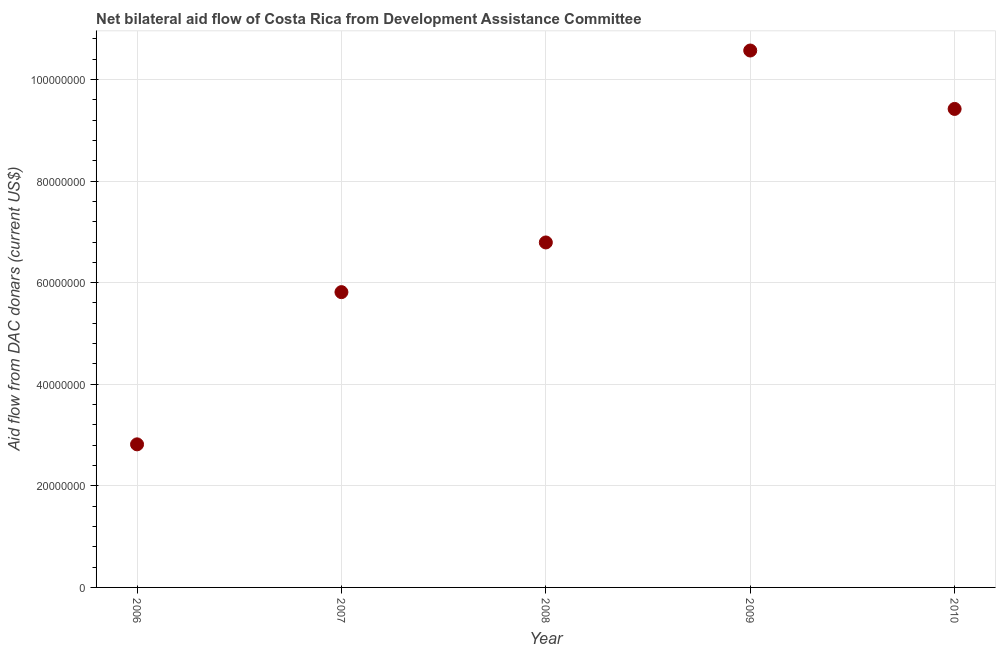What is the net bilateral aid flows from dac donors in 2010?
Your answer should be compact. 9.42e+07. Across all years, what is the maximum net bilateral aid flows from dac donors?
Keep it short and to the point. 1.06e+08. Across all years, what is the minimum net bilateral aid flows from dac donors?
Offer a very short reply. 2.82e+07. What is the sum of the net bilateral aid flows from dac donors?
Provide a succinct answer. 3.54e+08. What is the difference between the net bilateral aid flows from dac donors in 2006 and 2010?
Provide a succinct answer. -6.60e+07. What is the average net bilateral aid flows from dac donors per year?
Provide a succinct answer. 7.08e+07. What is the median net bilateral aid flows from dac donors?
Offer a terse response. 6.79e+07. What is the ratio of the net bilateral aid flows from dac donors in 2008 to that in 2009?
Offer a terse response. 0.64. Is the net bilateral aid flows from dac donors in 2006 less than that in 2008?
Ensure brevity in your answer.  Yes. Is the difference between the net bilateral aid flows from dac donors in 2006 and 2010 greater than the difference between any two years?
Your answer should be very brief. No. What is the difference between the highest and the second highest net bilateral aid flows from dac donors?
Provide a short and direct response. 1.15e+07. Is the sum of the net bilateral aid flows from dac donors in 2006 and 2009 greater than the maximum net bilateral aid flows from dac donors across all years?
Provide a succinct answer. Yes. What is the difference between the highest and the lowest net bilateral aid flows from dac donors?
Offer a very short reply. 7.75e+07. Does the net bilateral aid flows from dac donors monotonically increase over the years?
Your response must be concise. No. How many years are there in the graph?
Ensure brevity in your answer.  5. Does the graph contain grids?
Offer a terse response. Yes. What is the title of the graph?
Your answer should be very brief. Net bilateral aid flow of Costa Rica from Development Assistance Committee. What is the label or title of the X-axis?
Provide a succinct answer. Year. What is the label or title of the Y-axis?
Your answer should be very brief. Aid flow from DAC donars (current US$). What is the Aid flow from DAC donars (current US$) in 2006?
Your answer should be very brief. 2.82e+07. What is the Aid flow from DAC donars (current US$) in 2007?
Make the answer very short. 5.81e+07. What is the Aid flow from DAC donars (current US$) in 2008?
Give a very brief answer. 6.79e+07. What is the Aid flow from DAC donars (current US$) in 2009?
Give a very brief answer. 1.06e+08. What is the Aid flow from DAC donars (current US$) in 2010?
Offer a very short reply. 9.42e+07. What is the difference between the Aid flow from DAC donars (current US$) in 2006 and 2007?
Offer a very short reply. -3.00e+07. What is the difference between the Aid flow from DAC donars (current US$) in 2006 and 2008?
Ensure brevity in your answer.  -3.98e+07. What is the difference between the Aid flow from DAC donars (current US$) in 2006 and 2009?
Ensure brevity in your answer.  -7.75e+07. What is the difference between the Aid flow from DAC donars (current US$) in 2006 and 2010?
Your answer should be compact. -6.60e+07. What is the difference between the Aid flow from DAC donars (current US$) in 2007 and 2008?
Offer a terse response. -9.78e+06. What is the difference between the Aid flow from DAC donars (current US$) in 2007 and 2009?
Give a very brief answer. -4.76e+07. What is the difference between the Aid flow from DAC donars (current US$) in 2007 and 2010?
Give a very brief answer. -3.61e+07. What is the difference between the Aid flow from DAC donars (current US$) in 2008 and 2009?
Your answer should be compact. -3.78e+07. What is the difference between the Aid flow from DAC donars (current US$) in 2008 and 2010?
Provide a short and direct response. -2.63e+07. What is the difference between the Aid flow from DAC donars (current US$) in 2009 and 2010?
Your response must be concise. 1.15e+07. What is the ratio of the Aid flow from DAC donars (current US$) in 2006 to that in 2007?
Your answer should be compact. 0.48. What is the ratio of the Aid flow from DAC donars (current US$) in 2006 to that in 2008?
Offer a very short reply. 0.41. What is the ratio of the Aid flow from DAC donars (current US$) in 2006 to that in 2009?
Offer a terse response. 0.27. What is the ratio of the Aid flow from DAC donars (current US$) in 2006 to that in 2010?
Your answer should be very brief. 0.3. What is the ratio of the Aid flow from DAC donars (current US$) in 2007 to that in 2008?
Provide a succinct answer. 0.86. What is the ratio of the Aid flow from DAC donars (current US$) in 2007 to that in 2009?
Provide a succinct answer. 0.55. What is the ratio of the Aid flow from DAC donars (current US$) in 2007 to that in 2010?
Offer a very short reply. 0.62. What is the ratio of the Aid flow from DAC donars (current US$) in 2008 to that in 2009?
Provide a short and direct response. 0.64. What is the ratio of the Aid flow from DAC donars (current US$) in 2008 to that in 2010?
Provide a short and direct response. 0.72. What is the ratio of the Aid flow from DAC donars (current US$) in 2009 to that in 2010?
Provide a short and direct response. 1.12. 